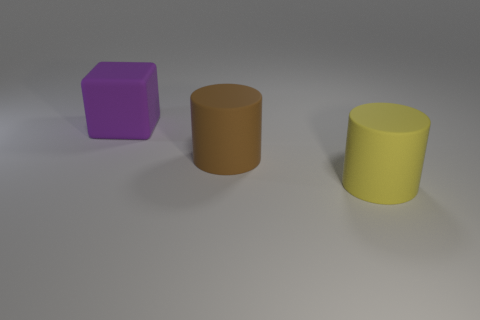Add 2 matte cubes. How many objects exist? 5 Subtract 1 cylinders. How many cylinders are left? 1 Subtract all cylinders. How many objects are left? 1 Subtract all purple cylinders. Subtract all blue spheres. How many cylinders are left? 2 Subtract all brown spheres. How many red cylinders are left? 0 Subtract all large matte things. Subtract all yellow metal things. How many objects are left? 0 Add 2 rubber cylinders. How many rubber cylinders are left? 4 Add 2 big cylinders. How many big cylinders exist? 4 Subtract 0 purple balls. How many objects are left? 3 